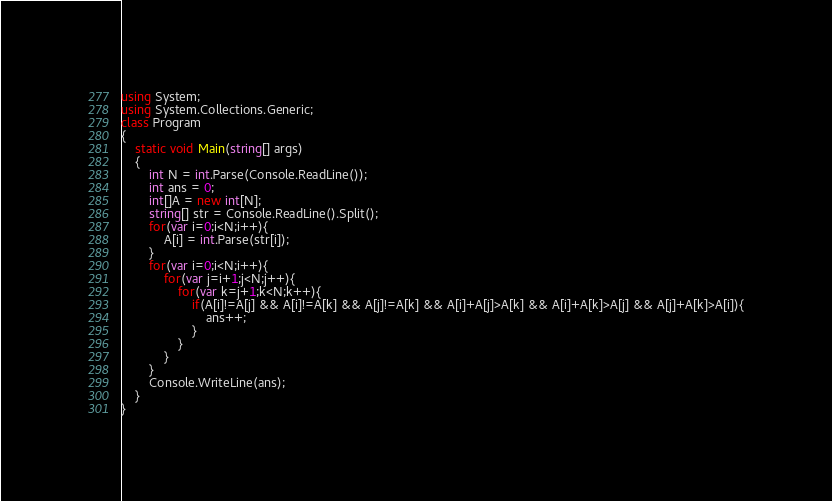Convert code to text. <code><loc_0><loc_0><loc_500><loc_500><_C#_>using System;
using System.Collections.Generic;
class Program
{
	static void Main(string[] args)
	{
		int N = int.Parse(Console.ReadLine());
		int ans = 0;
		int[]A = new int[N];
		string[] str = Console.ReadLine().Split();
		for(var i=0;i<N;i++){
			A[i] = int.Parse(str[i]);
		}
		for(var i=0;i<N;i++){
			for(var j=i+1;j<N;j++){
				for(var k=j+1;k<N;k++){
					if(A[i]!=A[j] && A[i]!=A[k] && A[j]!=A[k] && A[i]+A[j]>A[k] && A[i]+A[k]>A[j] && A[j]+A[k]>A[i]){
						ans++;
					}
				}
			}
		}
		Console.WriteLine(ans);
	}
}</code> 